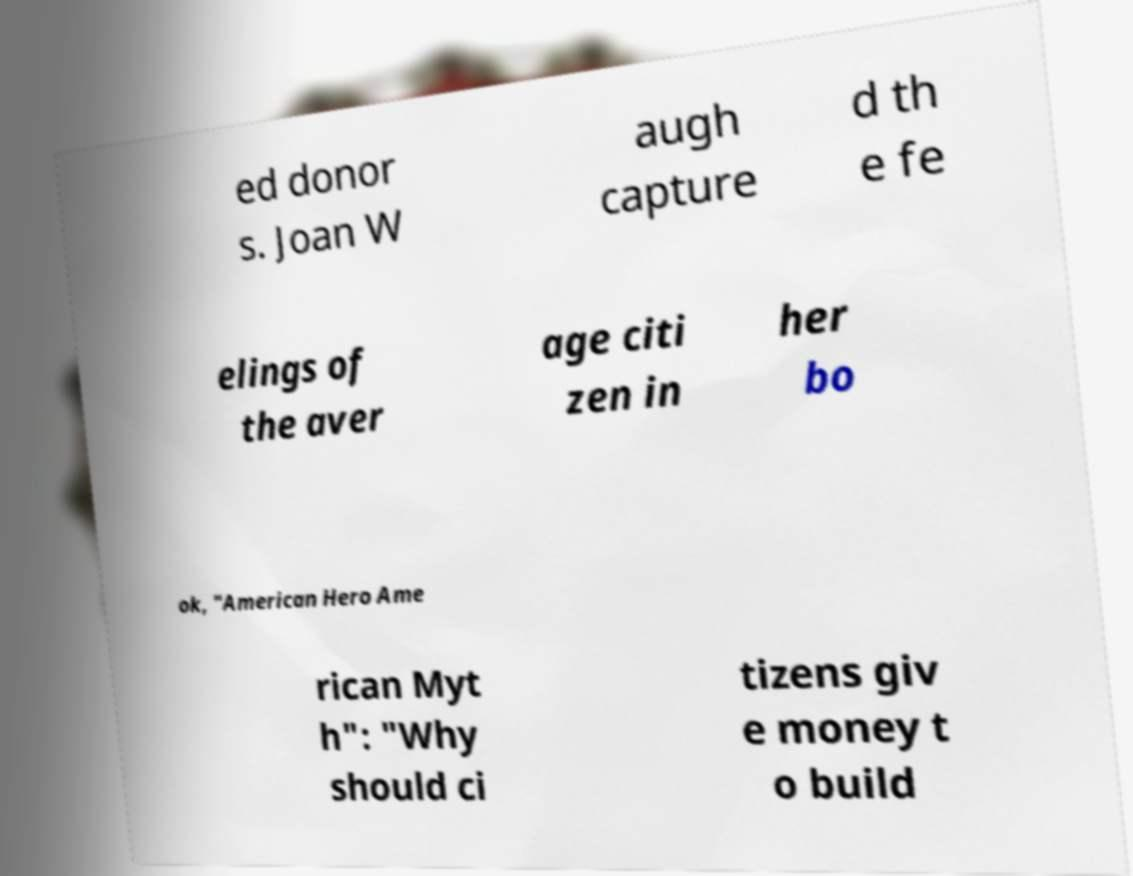I need the written content from this picture converted into text. Can you do that? ed donor s. Joan W augh capture d th e fe elings of the aver age citi zen in her bo ok, "American Hero Ame rican Myt h": "Why should ci tizens giv e money t o build 